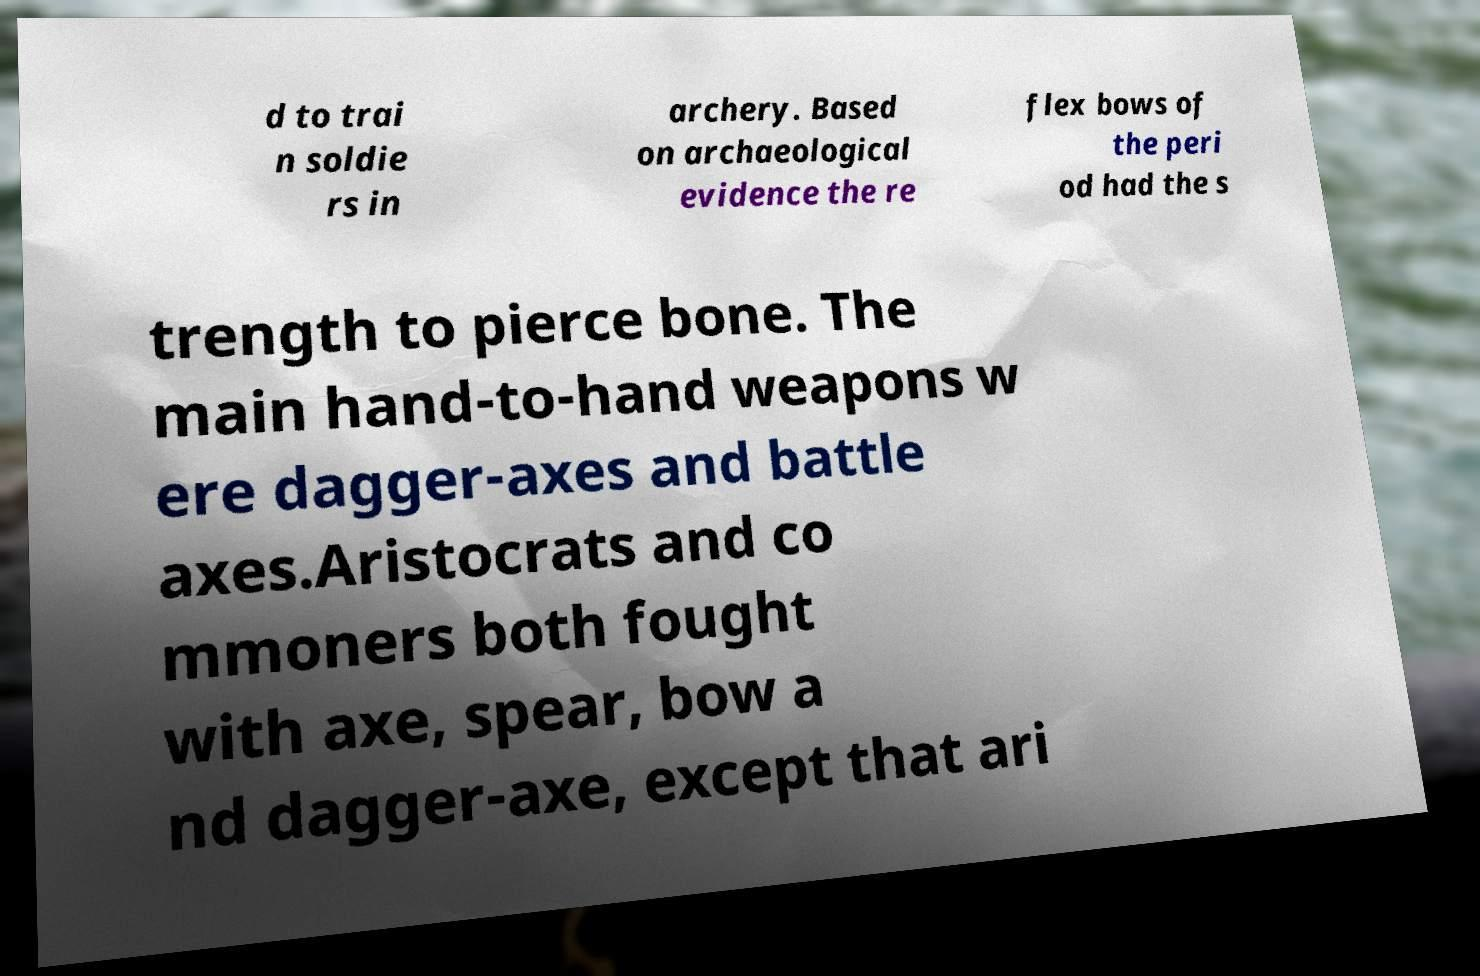I need the written content from this picture converted into text. Can you do that? d to trai n soldie rs in archery. Based on archaeological evidence the re flex bows of the peri od had the s trength to pierce bone. The main hand-to-hand weapons w ere dagger-axes and battle axes.Aristocrats and co mmoners both fought with axe, spear, bow a nd dagger-axe, except that ari 